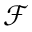<formula> <loc_0><loc_0><loc_500><loc_500>\mathcal { F }</formula> 